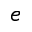Convert formula to latex. <formula><loc_0><loc_0><loc_500><loc_500>e</formula> 